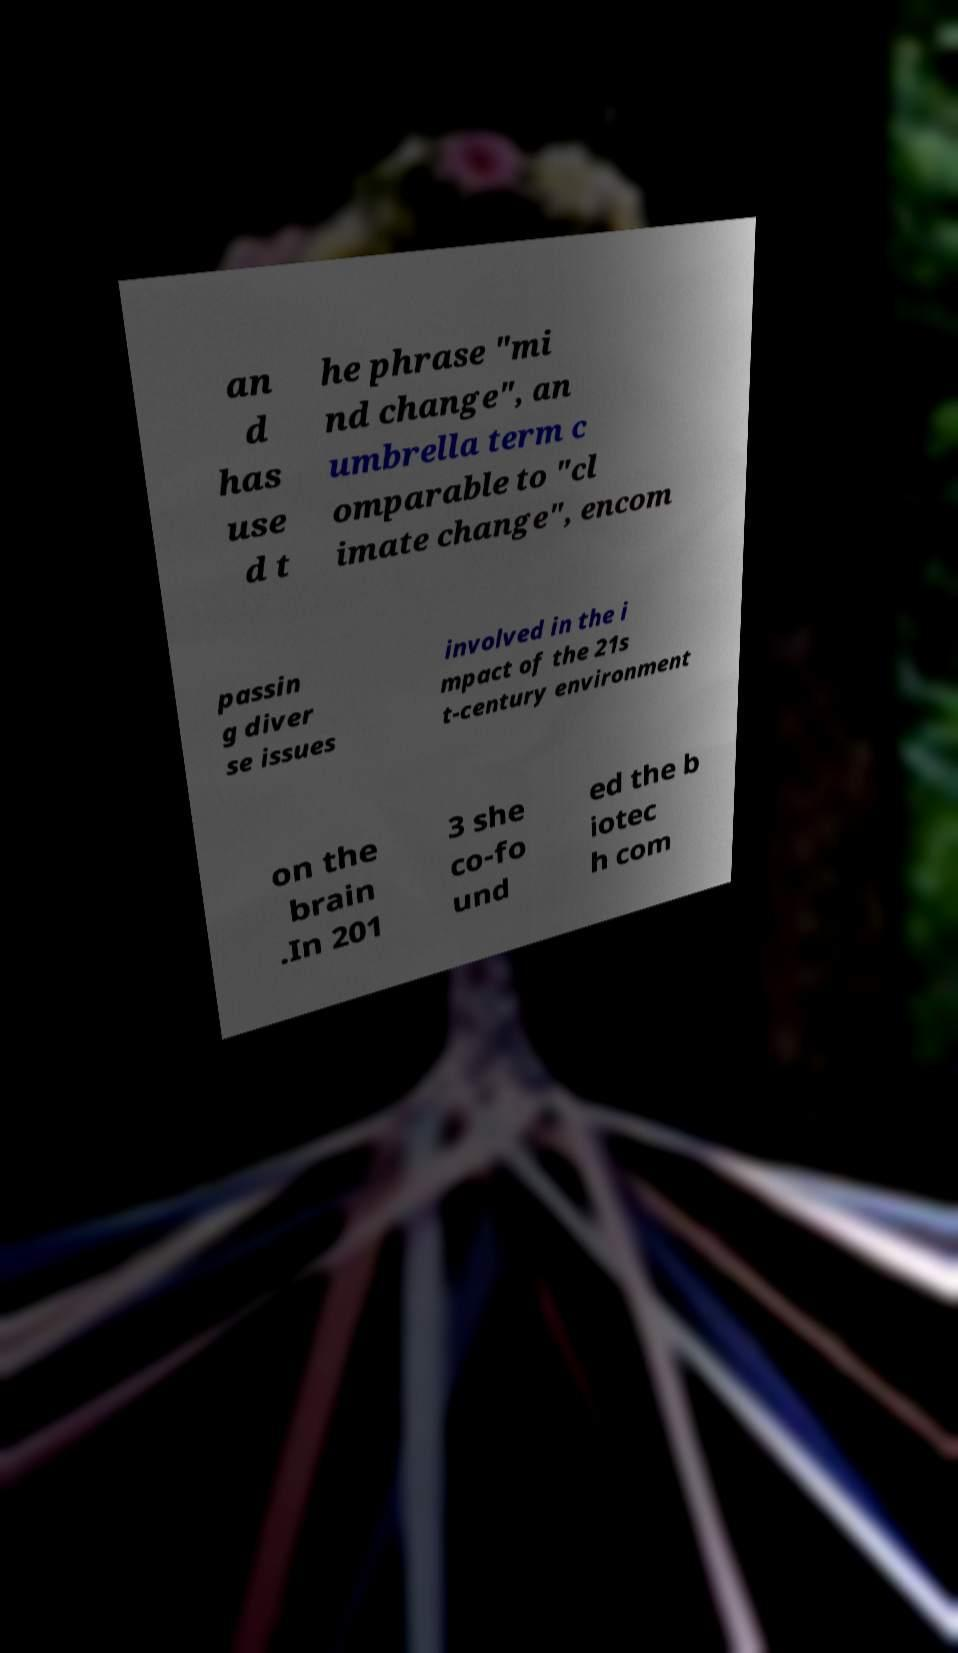Could you extract and type out the text from this image? an d has use d t he phrase "mi nd change", an umbrella term c omparable to "cl imate change", encom passin g diver se issues involved in the i mpact of the 21s t-century environment on the brain .In 201 3 she co-fo und ed the b iotec h com 